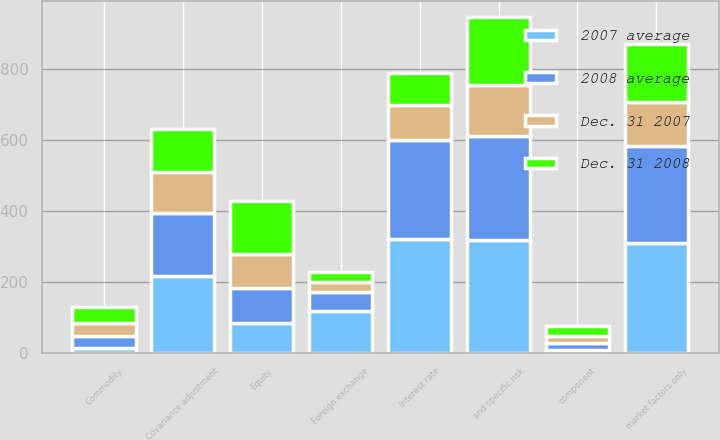Convert chart to OTSL. <chart><loc_0><loc_0><loc_500><loc_500><stacked_bar_chart><ecel><fcel>Interest rate<fcel>Foreign exchange<fcel>Equity<fcel>Commodity<fcel>Covariance adjustment<fcel>and specific risk<fcel>component<fcel>market factors only<nl><fcel>2007 average<fcel>320<fcel>118<fcel>84<fcel>15<fcel>218<fcel>319<fcel>8<fcel>311<nl><fcel>2008 average<fcel>280<fcel>54<fcel>99<fcel>34<fcel>175<fcel>292<fcel>21<fcel>271<nl><fcel>Dec. 31 2008<fcel>89<fcel>28<fcel>150<fcel>45<fcel>121<fcel>191<fcel>28<fcel>163<nl><fcel>Dec. 31 2007<fcel>98<fcel>29<fcel>96<fcel>35<fcel>116<fcel>142<fcel>19<fcel>123<nl></chart> 